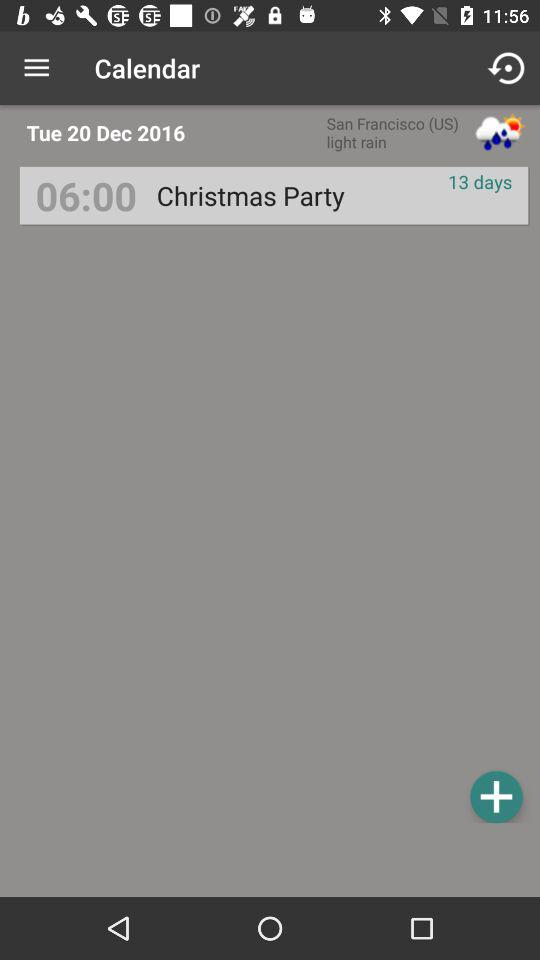What's the reminder time for "Christmas party"? The reminder time is 6:00. 